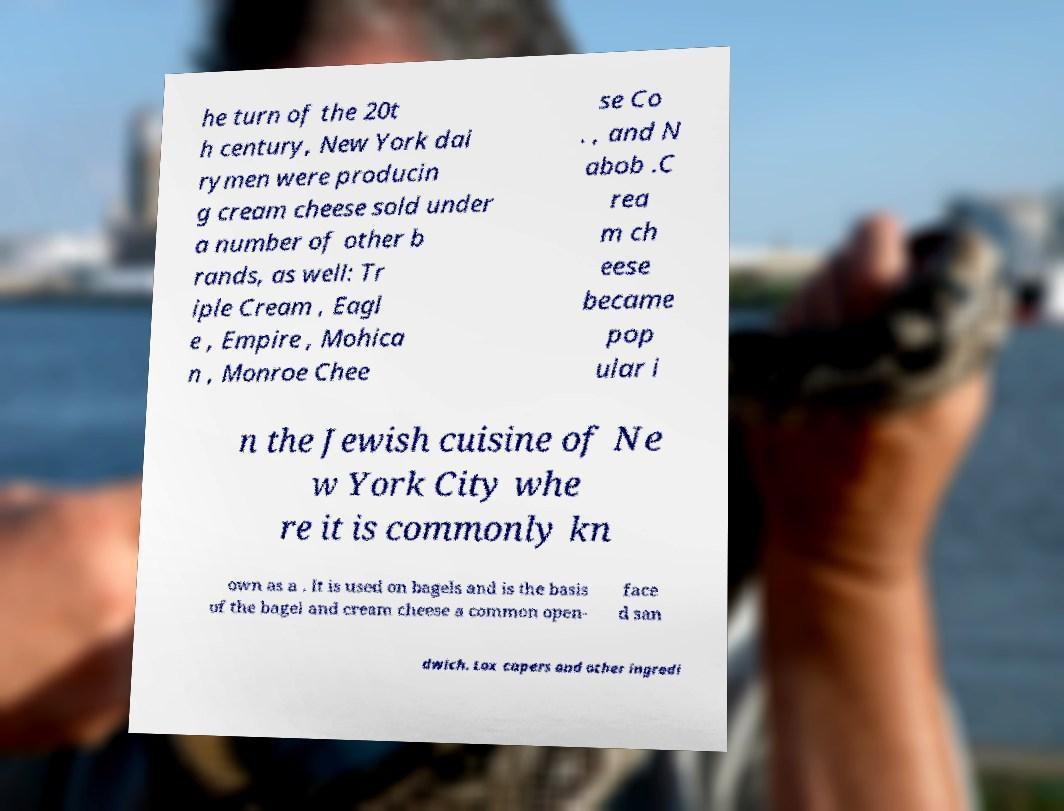Could you assist in decoding the text presented in this image and type it out clearly? he turn of the 20t h century, New York dai rymen were producin g cream cheese sold under a number of other b rands, as well: Tr iple Cream , Eagl e , Empire , Mohica n , Monroe Chee se Co . , and N abob .C rea m ch eese became pop ular i n the Jewish cuisine of Ne w York City whe re it is commonly kn own as a . It is used on bagels and is the basis of the bagel and cream cheese a common open- face d san dwich. Lox capers and other ingredi 